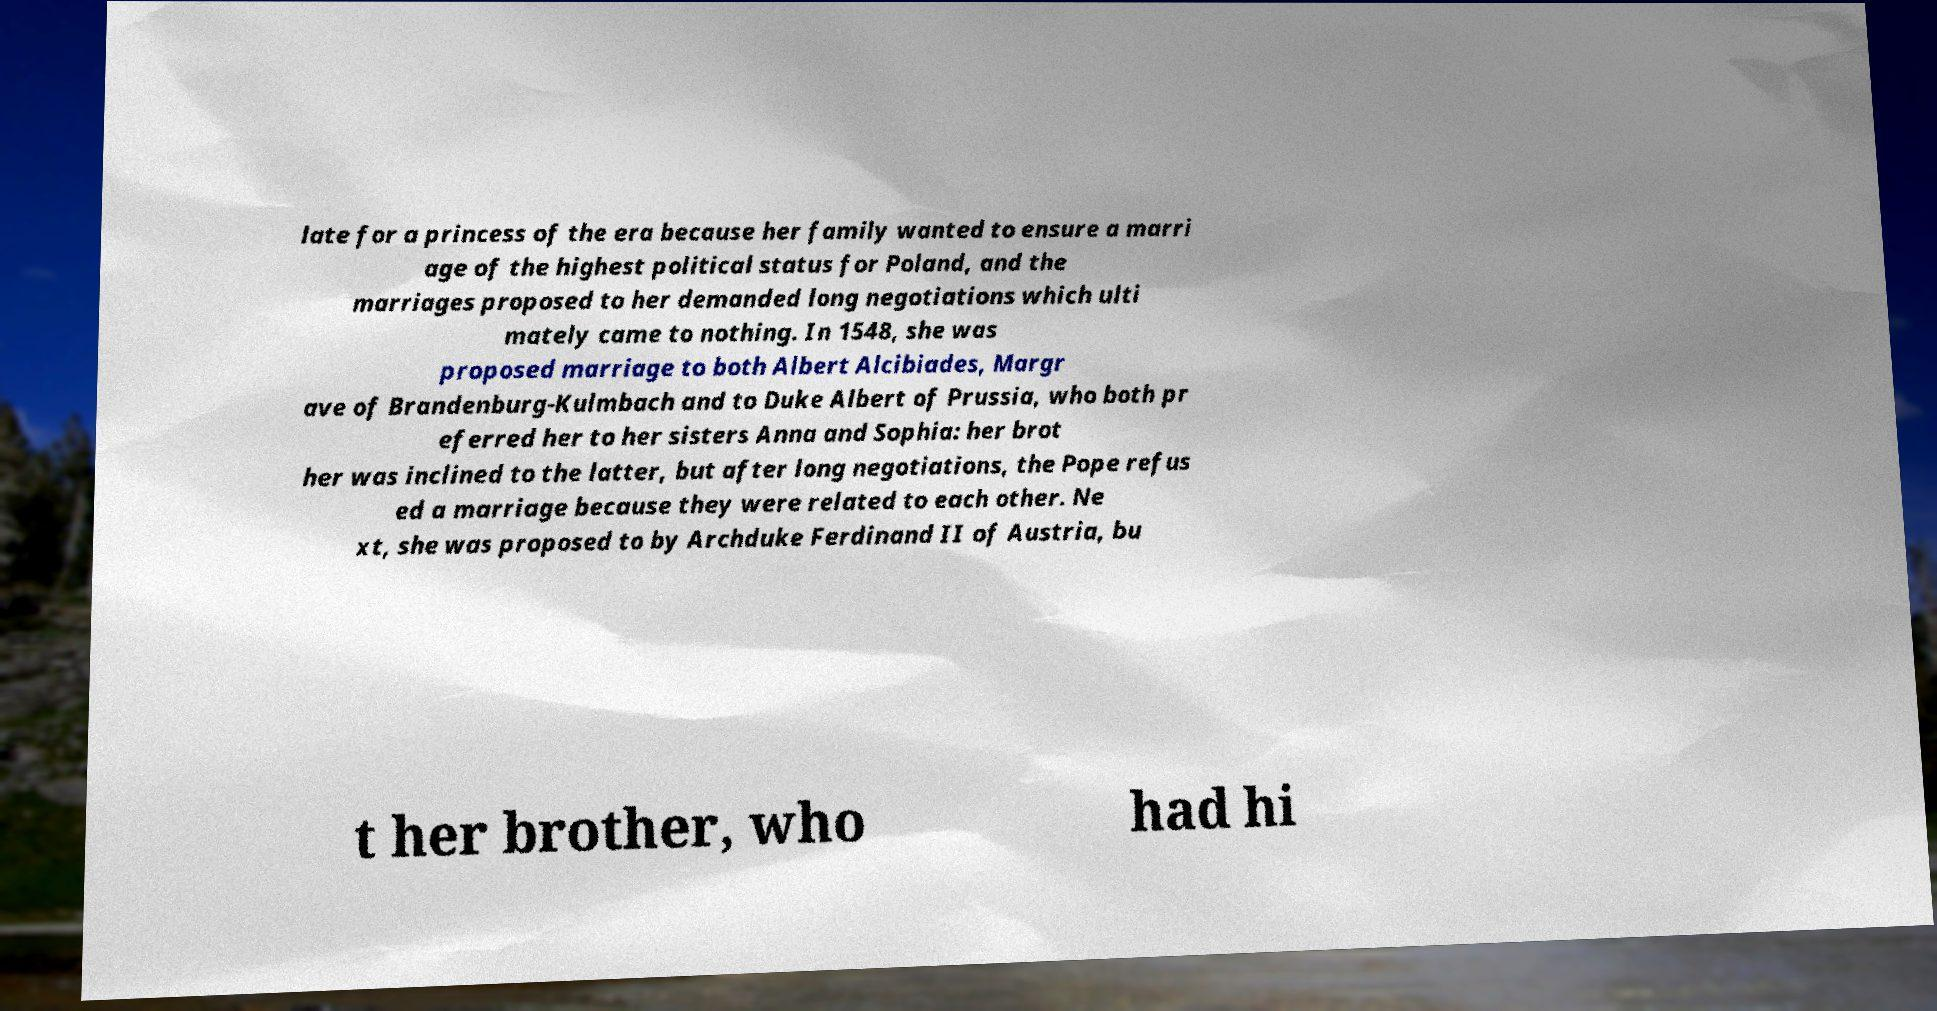Can you read and provide the text displayed in the image?This photo seems to have some interesting text. Can you extract and type it out for me? late for a princess of the era because her family wanted to ensure a marri age of the highest political status for Poland, and the marriages proposed to her demanded long negotiations which ulti mately came to nothing. In 1548, she was proposed marriage to both Albert Alcibiades, Margr ave of Brandenburg-Kulmbach and to Duke Albert of Prussia, who both pr eferred her to her sisters Anna and Sophia: her brot her was inclined to the latter, but after long negotiations, the Pope refus ed a marriage because they were related to each other. Ne xt, she was proposed to by Archduke Ferdinand II of Austria, bu t her brother, who had hi 